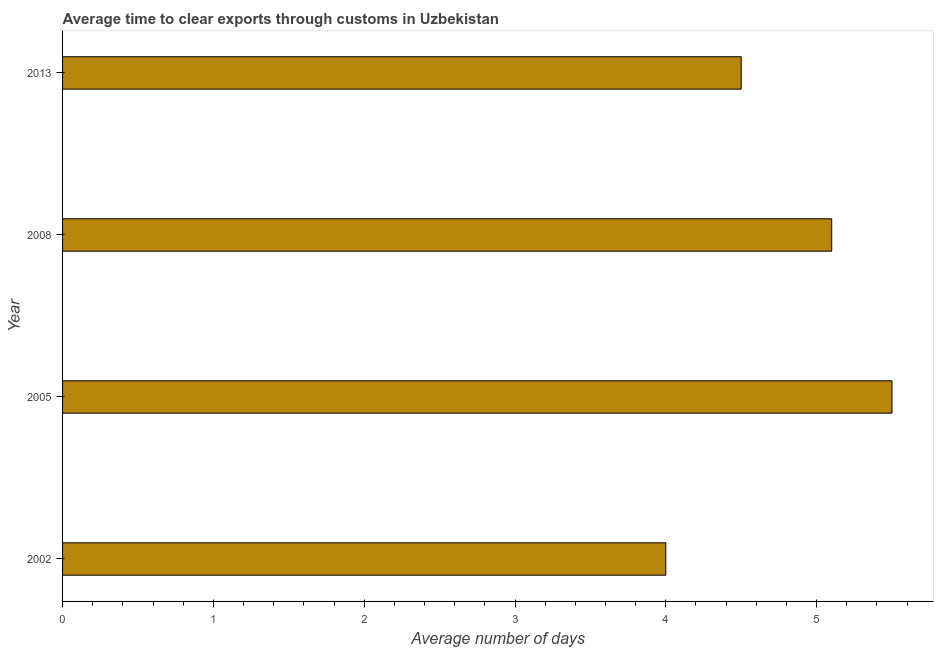What is the title of the graph?
Your answer should be very brief. Average time to clear exports through customs in Uzbekistan. What is the label or title of the X-axis?
Provide a succinct answer. Average number of days. What is the label or title of the Y-axis?
Offer a very short reply. Year. What is the time to clear exports through customs in 2002?
Your answer should be compact. 4. Across all years, what is the minimum time to clear exports through customs?
Provide a succinct answer. 4. In which year was the time to clear exports through customs minimum?
Your answer should be very brief. 2002. What is the sum of the time to clear exports through customs?
Make the answer very short. 19.1. What is the difference between the time to clear exports through customs in 2005 and 2008?
Your response must be concise. 0.4. What is the average time to clear exports through customs per year?
Offer a very short reply. 4.78. What is the median time to clear exports through customs?
Keep it short and to the point. 4.8. What is the ratio of the time to clear exports through customs in 2002 to that in 2013?
Your response must be concise. 0.89. What is the difference between the highest and the second highest time to clear exports through customs?
Your response must be concise. 0.4. Is the sum of the time to clear exports through customs in 2002 and 2013 greater than the maximum time to clear exports through customs across all years?
Give a very brief answer. Yes. In how many years, is the time to clear exports through customs greater than the average time to clear exports through customs taken over all years?
Ensure brevity in your answer.  2. Are all the bars in the graph horizontal?
Make the answer very short. Yes. How many years are there in the graph?
Your answer should be compact. 4. Are the values on the major ticks of X-axis written in scientific E-notation?
Ensure brevity in your answer.  No. What is the Average number of days of 2005?
Offer a terse response. 5.5. What is the Average number of days of 2008?
Your answer should be very brief. 5.1. What is the difference between the Average number of days in 2002 and 2005?
Provide a succinct answer. -1.5. What is the difference between the Average number of days in 2002 and 2008?
Provide a succinct answer. -1.1. What is the difference between the Average number of days in 2002 and 2013?
Keep it short and to the point. -0.5. What is the difference between the Average number of days in 2005 and 2013?
Provide a succinct answer. 1. What is the ratio of the Average number of days in 2002 to that in 2005?
Ensure brevity in your answer.  0.73. What is the ratio of the Average number of days in 2002 to that in 2008?
Make the answer very short. 0.78. What is the ratio of the Average number of days in 2002 to that in 2013?
Offer a very short reply. 0.89. What is the ratio of the Average number of days in 2005 to that in 2008?
Keep it short and to the point. 1.08. What is the ratio of the Average number of days in 2005 to that in 2013?
Give a very brief answer. 1.22. What is the ratio of the Average number of days in 2008 to that in 2013?
Make the answer very short. 1.13. 